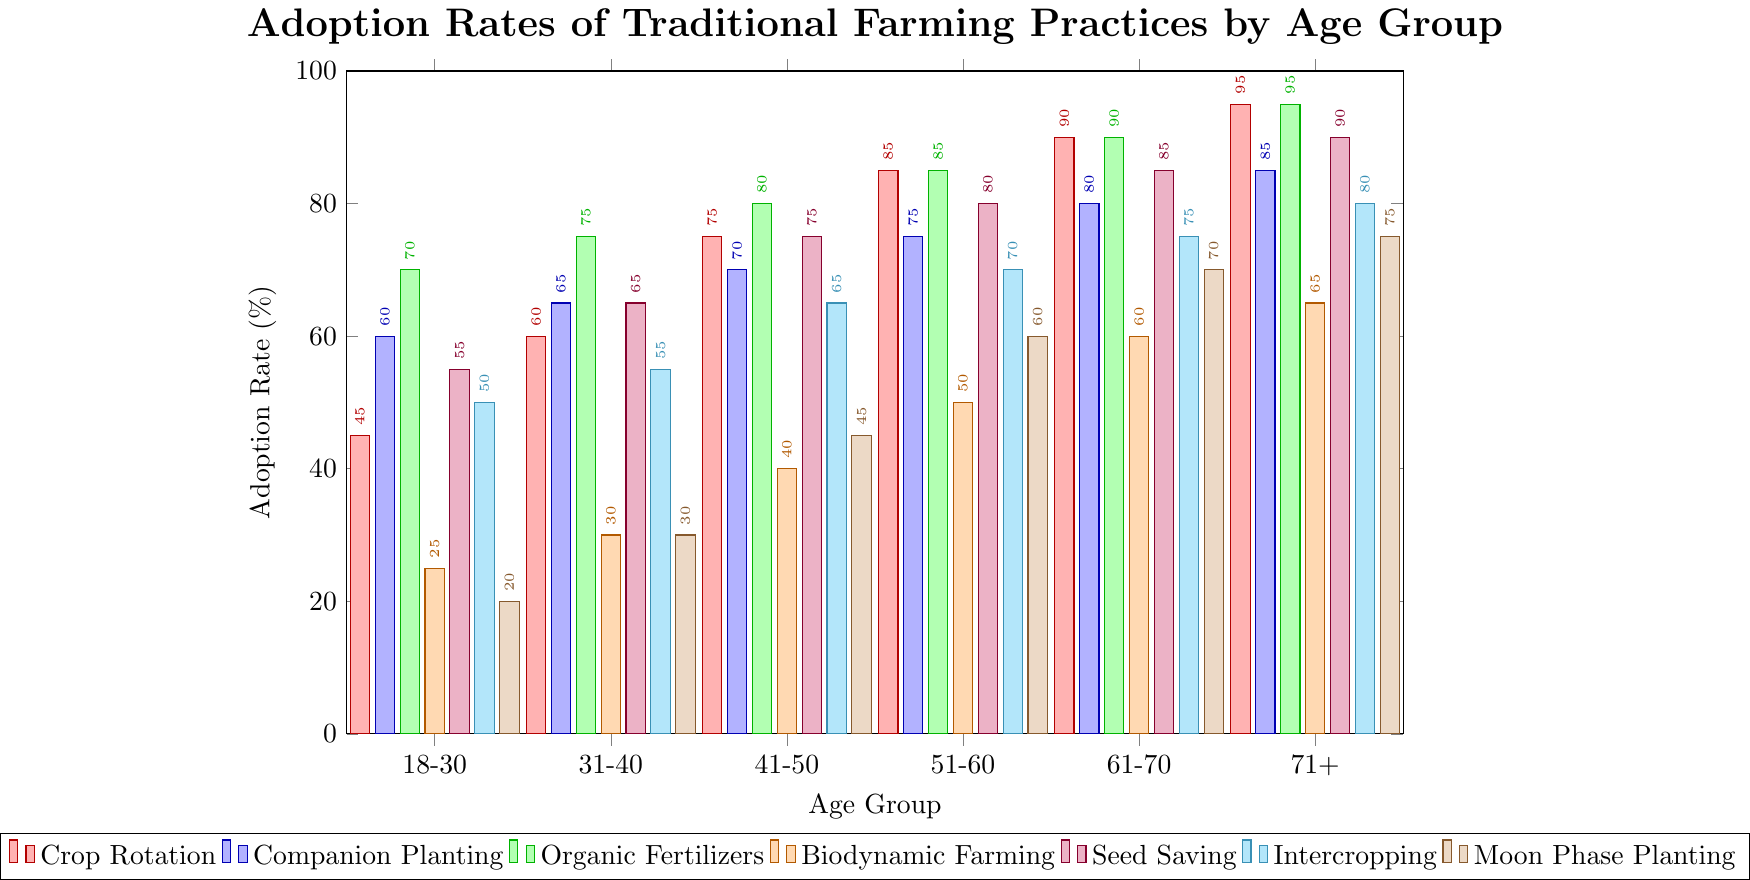Which age group has the highest adoption rate for Crop Rotation? Looking at the heights of the bars representing Crop Rotation, the bar for the 71+ age group is the tallest.
Answer: 71+ How does the adoption rate of Seed Saving vary across different age groups? The heights of the bars represent the adoption rates for Seed Saving among different age groups. They increase progressively from 18-30 (55%) to 71+ (90%). The pattern shows an increasing trend.
Answer: Increases progressively Which traditional farming practice shows the lowest adoption rate for the 18-30 age group? Observing the bars corresponding to each practice for the 18-30 age group, the shortest bar is for Moon Phase Planting at 20%.
Answer: Moon Phase Planting Compare the adoption rates of Biodynamic Farming and Organic Fertilizers in the 51-60 age group. Which is higher and by how much? For the age group 51-60, the adoption rate for Biodynamic Farming is 50%, while for Organic Fertilizers, it is 85%. Subtracting the two values, 85% - 50%, gives us 35%.
Answer: Organic Fertilizers by 35% Which age group has the highest average adoption rate across all the farming practices? Calculate the average for each age group by adding the adoption rates of all practices and divide by the total number of practices. The age group with the highest average is 71+: (95+85+95+65+90+80+75)/7 = 83%.
Answer: 71+ For the age group 41-50, which practice has the closest adoption rate to the average rate of that group? Calculate the average adoption rate: (75+70+80+40+75+65+45)/7 = 64.29%. The closest practice rate to the average is Intercropping at 65%.
Answer: Intercropping Among Companion Planting and Moon Phase Planting, which practice shows a wider range of adoption rates between the youngest and oldest age groups? The range for Companion Planting is 85% - 60% = 25%. The range for Moon Phase Planting is 75% - 20% = 55%. Moon Phase Planting has a wider range.
Answer: Moon Phase Planting Find the sum of adoption rates for Crop Rotation and Seed Saving for the 31-40 age group. Add the adoption rates for Crop Rotation (60%) and Seed Saving (65%) for the age group 31-40. The sum is 60% + 65% = 125%.
Answer: 125% What is the height difference between the Organic Fertilizers bar for the 61-70 and the Biodynamic Farming bar for the same age group? The height of the bar for Organic Fertilizers is 90%, and for Biodynamic Farming, it is 60%. The difference is 90% - 60% = 30%.
Answer: 30% 